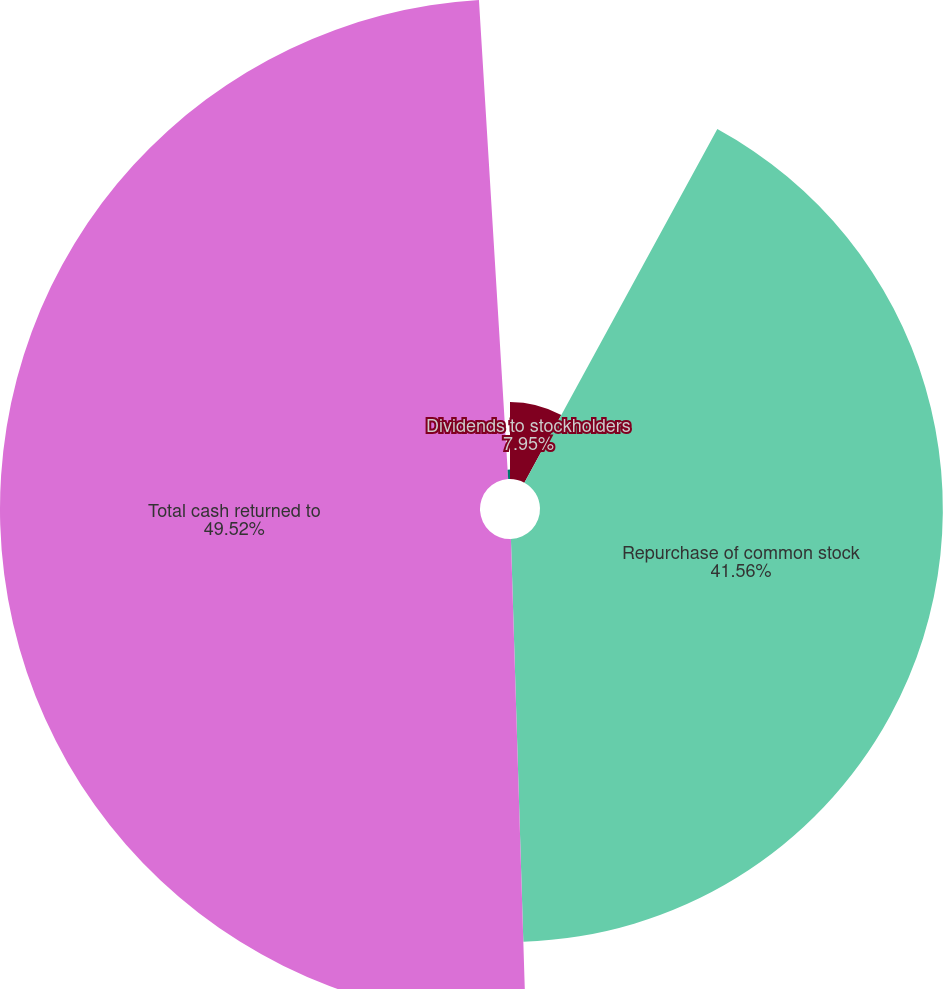<chart> <loc_0><loc_0><loc_500><loc_500><pie_chart><fcel>Dividends to stockholders<fcel>Repurchase of common stock<fcel>Total cash returned to<fcel>Number of shares repurchased<nl><fcel>7.95%<fcel>41.56%<fcel>49.52%<fcel>0.97%<nl></chart> 